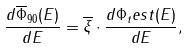Convert formula to latex. <formula><loc_0><loc_0><loc_500><loc_500>\frac { d \overline { \Phi } _ { 9 0 } ( E ) } { d E } = \overline { \xi } \cdot \frac { d \Phi _ { t } e s t ( E ) } { d E } ,</formula> 